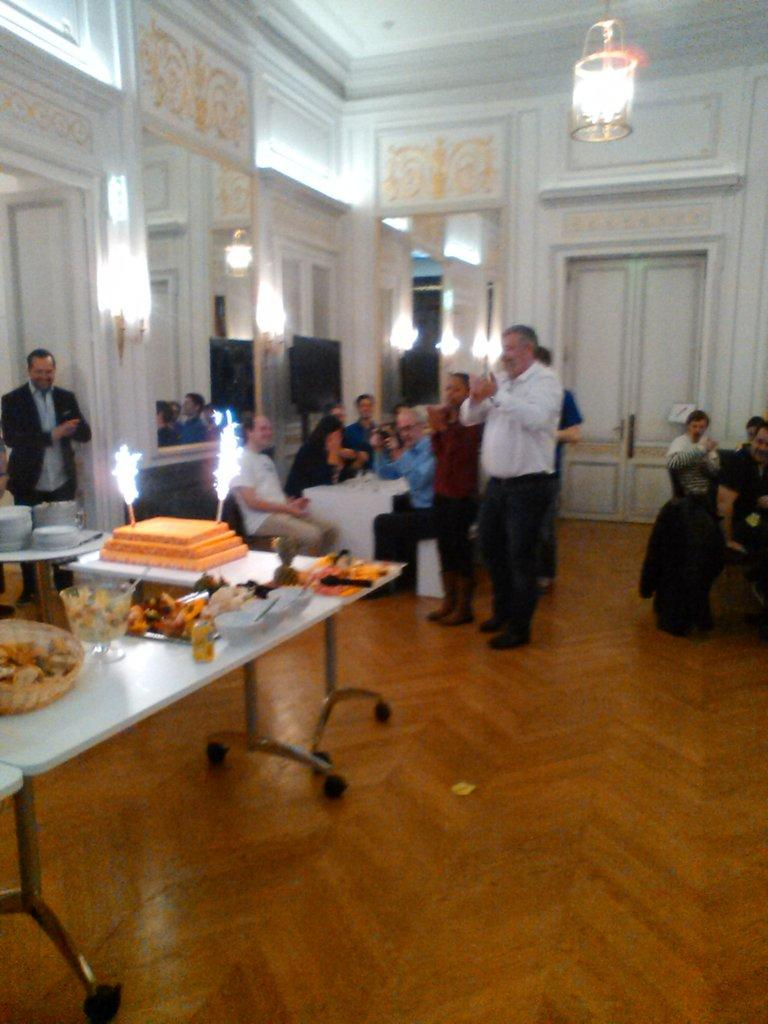How many people are in the image? There is a group of people in the image. What are some of the people doing in the image? Some people are sitting on chairs, while others are standing on the floor. What is present in the image besides the people? There is a table in the image. What can be found on the table? There are objects on the table. What type of potato is being rewarded at the market in the image? There is no potato, reward, or market present in the image. 